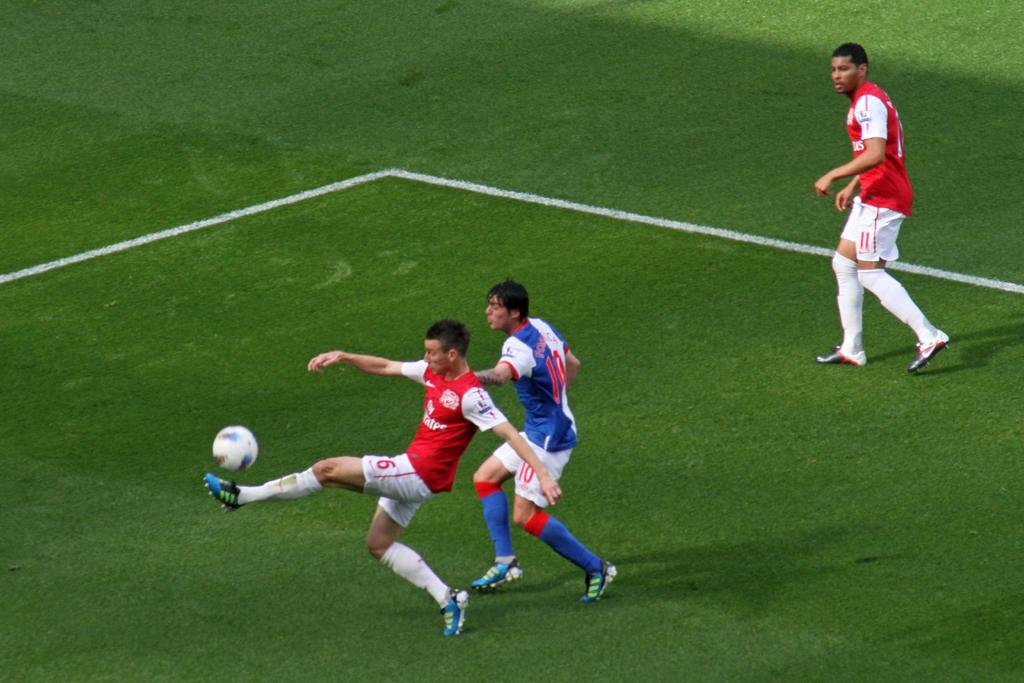How many people are playing football in the image? There are three men in the image. What are the men doing in the image? The men are playing football. Where is the football game taking place? The game is taking place on a grassy land. What colors are the dresses of two of the men? Two of the men are wearing red and white color dress. What color is the dress of the third man? One man is wearing blue and white color dress. Reasoning: Let's think step by following the steps to produce the conversation. We start by identifying the main subject of the image, which is the three men playing football. Then, we describe the activity they are engaged in, which is playing football. Next, we mention the location of the game, which is on a grassy land. Finally, we provide details about the colors of the men's dresses. Absurd Question/Answer: How many horses are running alongside the men in the image? There are no horses present in the image; it features three men playing football on a grassy land. What is the wind doing in the image? There is no mention of wind in the image, as it focuses on the men playing football on a grassy land. How many steps are required for the men to complete a touchdown in the image? There is no mention of a touchdown or steps in the image, as it focuses on the men playing football on a grassy land. 